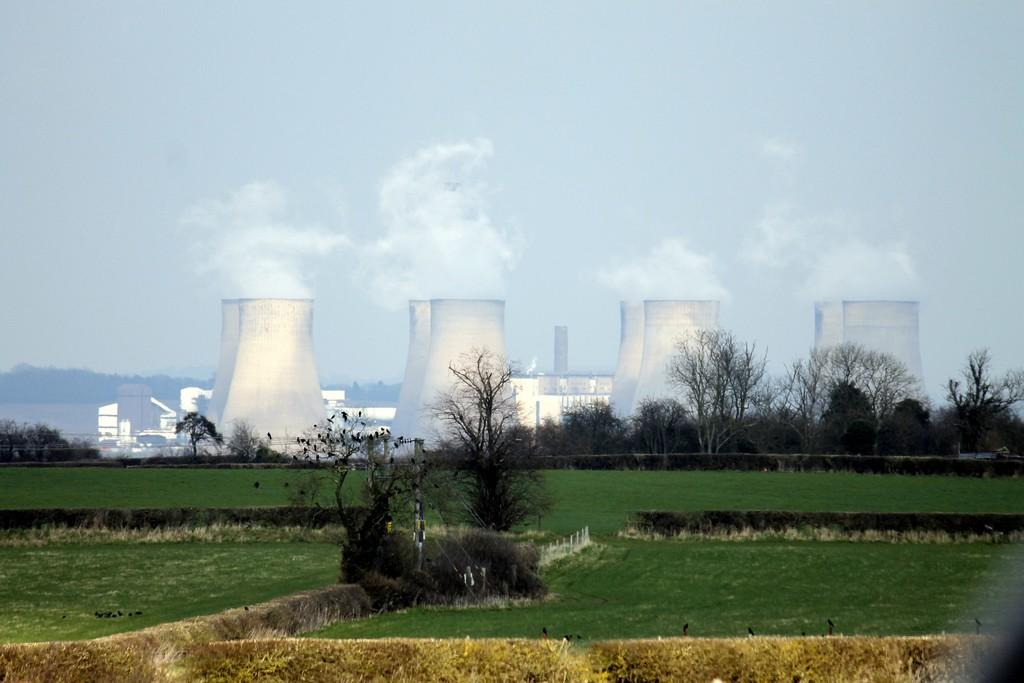What type of vegetation is present in the image? There is a lot of grass in the image. What other natural elements can be seen in the image? There are trees in the image. What type of man-made structure is visible in the image? There is a nuclear power plant in the image. Are there any other buildings or structures in the image? Yes, there are buildings in the image. What type of loaf can be seen on the floor in the image? There is no loaf present in the image. What type of flooring is visible in the image? The image does not show any flooring, as it appears to be an outdoor scene with grass and trees. 